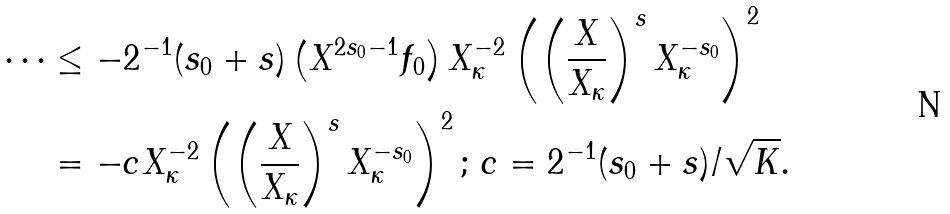<formula> <loc_0><loc_0><loc_500><loc_500>\cdots & \leq - 2 ^ { - 1 } ( s _ { 0 } + s ) \left ( X ^ { 2 s _ { 0 } - 1 } f _ { 0 } \right ) X _ { \kappa } ^ { - 2 } \left ( \left ( \frac { X } { X _ { \kappa } } \right ) ^ { s } X _ { \kappa } ^ { - s _ { 0 } } \right ) ^ { 2 } \\ & = - c X _ { \kappa } ^ { - 2 } \left ( \left ( \frac { X } { X _ { \kappa } } \right ) ^ { s } X _ { \kappa } ^ { - s _ { 0 } } \right ) ^ { 2 } ; \, c = 2 ^ { - 1 } ( s _ { 0 } + s ) / \sqrt { K } .</formula> 